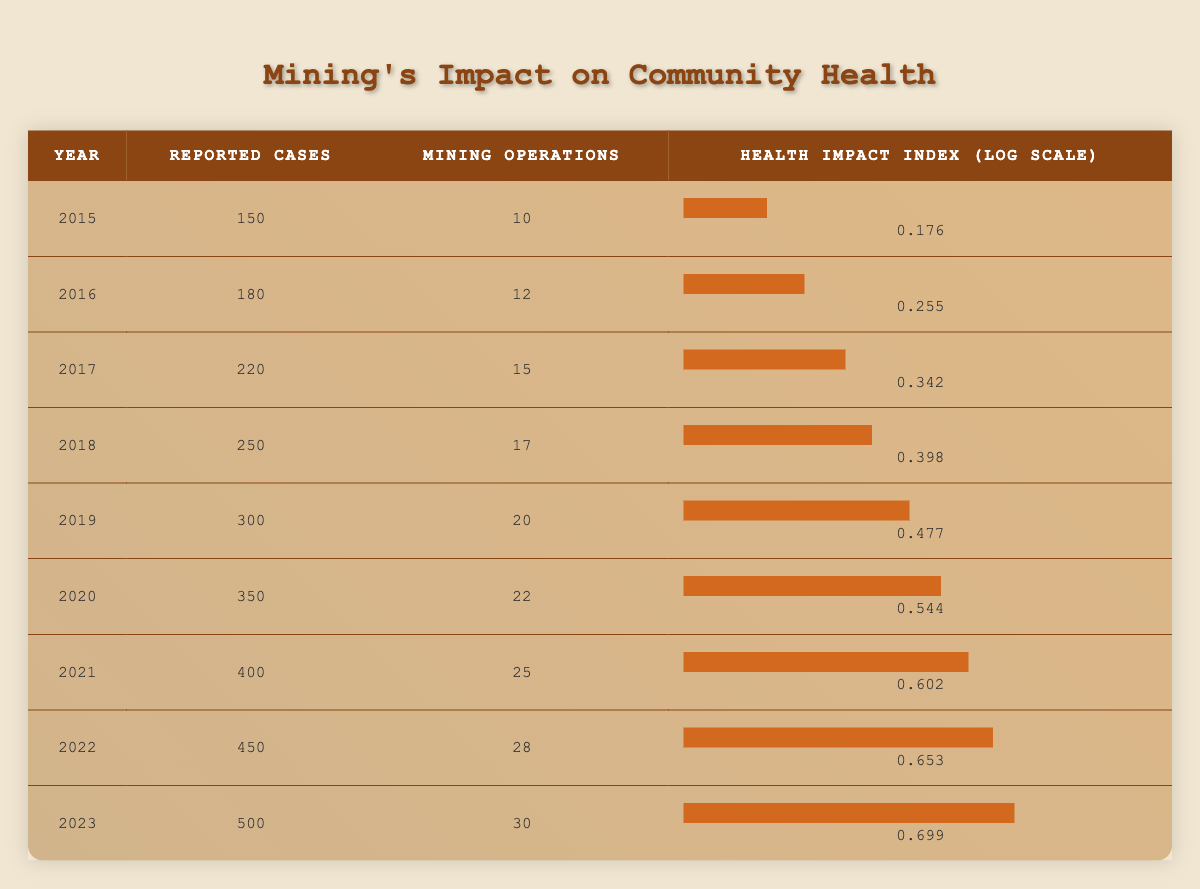What was the highest number of reported health cases in a year? The highest number of reported cases is found in the year 2023 with 500 cases. We can see this by scanning the "Reported Cases" column.
Answer: 500 In what year did the number of mining operations first exceed 20? The year when the number of mining operations exceeded 20 is 2019, which can be verified by checking the "Mining Operations" column for values greater than 20.
Answer: 2019 What is the health impact index for the year with the lowest reported cases? The year with the lowest reported cases is 2015, and the health impact index for that year is 0.176, found in the last column for that specific year.
Answer: 0.176 How many more reported cases were there in 2023 compared to 2015? To find the difference, subtract the number of reported cases in 2015 (150) from those in 2023 (500). The calculation is 500 - 150 = 350.
Answer: 350 Is it true that reported health cases increased every year from 2015 to 2023? Yes, by reviewing the "Reported Cases" column, we can see that there is a consistent increase each year from 150 in 2015 to 500 in 2023.
Answer: Yes What was the average number of mining operations from 2015 to 2023? To compute the average, sum the mining operations across all years (10 + 12 + 15 + 17 + 20 + 22 + 25 + 28 + 30 =  159) and divide by the number of years (9). So the average is 159 / 9 = 17.67.
Answer: 17.67 In which year did reported cases increase by more than 50 from the previous year? The years when the increase is greater than 50 are 2018 (from 220 to 250) and 2019 (from 250 to 300). This can be determined by comparing each year's cases to the previous year.
Answer: 2018, 2019 What is the percentage increase in mining operations from 2015 to 2023? The percentage increase is calculated by taking the difference in mining operations (30 - 10 = 20), dividing by the initial number (10), and multiplying by 100. This results in (20 / 10) * 100 = 200%.
Answer: 200% Which year had the highest health impact index, and what was its value? The highest health impact index is in 2023 with a value of 0.699, as seen by checking the "Health Impact Index" column for values.
Answer: 2023, 0.699 